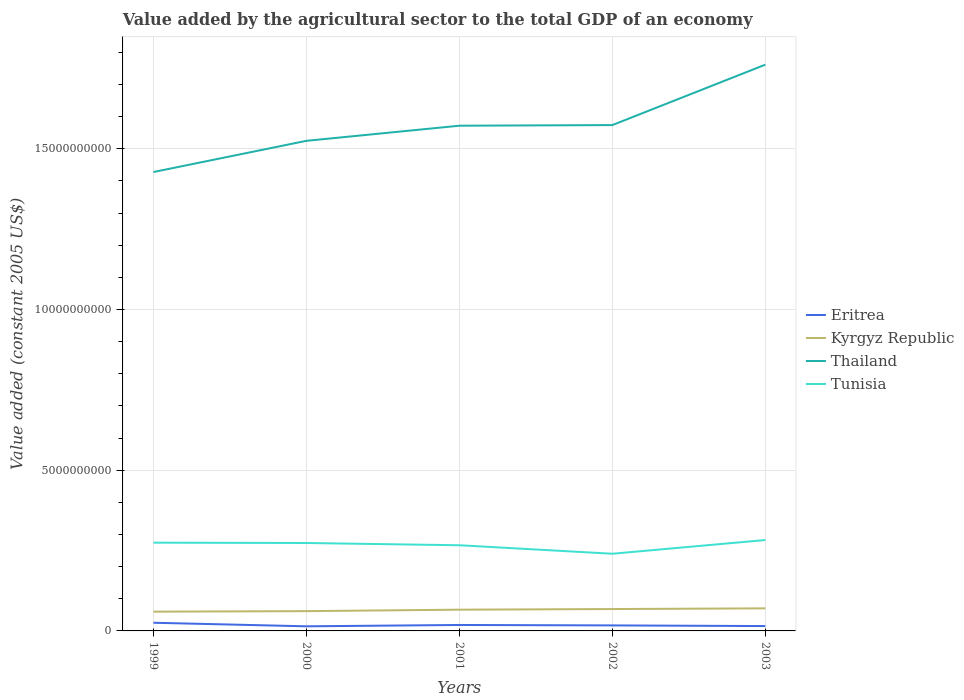Across all years, what is the maximum value added by the agricultural sector in Tunisia?
Ensure brevity in your answer.  2.40e+09. In which year was the value added by the agricultural sector in Kyrgyz Republic maximum?
Offer a terse response. 1999. What is the total value added by the agricultural sector in Eritrea in the graph?
Ensure brevity in your answer.  2.03e+07. What is the difference between the highest and the second highest value added by the agricultural sector in Kyrgyz Republic?
Ensure brevity in your answer.  1.03e+08. How many lines are there?
Your response must be concise. 4. Are the values on the major ticks of Y-axis written in scientific E-notation?
Your response must be concise. No. Does the graph contain any zero values?
Provide a succinct answer. No. What is the title of the graph?
Provide a short and direct response. Value added by the agricultural sector to the total GDP of an economy. What is the label or title of the X-axis?
Offer a terse response. Years. What is the label or title of the Y-axis?
Keep it short and to the point. Value added (constant 2005 US$). What is the Value added (constant 2005 US$) in Eritrea in 1999?
Give a very brief answer. 2.54e+08. What is the Value added (constant 2005 US$) of Kyrgyz Republic in 1999?
Ensure brevity in your answer.  5.99e+08. What is the Value added (constant 2005 US$) in Thailand in 1999?
Keep it short and to the point. 1.43e+1. What is the Value added (constant 2005 US$) of Tunisia in 1999?
Your answer should be very brief. 2.75e+09. What is the Value added (constant 2005 US$) of Eritrea in 2000?
Provide a succinct answer. 1.44e+08. What is the Value added (constant 2005 US$) of Kyrgyz Republic in 2000?
Your answer should be very brief. 6.15e+08. What is the Value added (constant 2005 US$) of Thailand in 2000?
Provide a succinct answer. 1.52e+1. What is the Value added (constant 2005 US$) of Tunisia in 2000?
Your answer should be compact. 2.74e+09. What is the Value added (constant 2005 US$) of Eritrea in 2001?
Your response must be concise. 1.85e+08. What is the Value added (constant 2005 US$) in Kyrgyz Republic in 2001?
Offer a very short reply. 6.61e+08. What is the Value added (constant 2005 US$) of Thailand in 2001?
Ensure brevity in your answer.  1.57e+1. What is the Value added (constant 2005 US$) of Tunisia in 2001?
Provide a short and direct response. 2.67e+09. What is the Value added (constant 2005 US$) in Eritrea in 2002?
Offer a very short reply. 1.71e+08. What is the Value added (constant 2005 US$) in Kyrgyz Republic in 2002?
Your answer should be compact. 6.81e+08. What is the Value added (constant 2005 US$) in Thailand in 2002?
Your answer should be very brief. 1.57e+1. What is the Value added (constant 2005 US$) in Tunisia in 2002?
Offer a very short reply. 2.40e+09. What is the Value added (constant 2005 US$) in Eritrea in 2003?
Keep it short and to the point. 1.51e+08. What is the Value added (constant 2005 US$) of Kyrgyz Republic in 2003?
Your answer should be very brief. 7.02e+08. What is the Value added (constant 2005 US$) in Thailand in 2003?
Keep it short and to the point. 1.76e+1. What is the Value added (constant 2005 US$) of Tunisia in 2003?
Your answer should be compact. 2.83e+09. Across all years, what is the maximum Value added (constant 2005 US$) in Eritrea?
Your response must be concise. 2.54e+08. Across all years, what is the maximum Value added (constant 2005 US$) in Kyrgyz Republic?
Your answer should be compact. 7.02e+08. Across all years, what is the maximum Value added (constant 2005 US$) of Thailand?
Provide a short and direct response. 1.76e+1. Across all years, what is the maximum Value added (constant 2005 US$) of Tunisia?
Provide a succinct answer. 2.83e+09. Across all years, what is the minimum Value added (constant 2005 US$) in Eritrea?
Ensure brevity in your answer.  1.44e+08. Across all years, what is the minimum Value added (constant 2005 US$) in Kyrgyz Republic?
Offer a terse response. 5.99e+08. Across all years, what is the minimum Value added (constant 2005 US$) in Thailand?
Make the answer very short. 1.43e+1. Across all years, what is the minimum Value added (constant 2005 US$) in Tunisia?
Ensure brevity in your answer.  2.40e+09. What is the total Value added (constant 2005 US$) of Eritrea in the graph?
Ensure brevity in your answer.  9.06e+08. What is the total Value added (constant 2005 US$) of Kyrgyz Republic in the graph?
Your response must be concise. 3.26e+09. What is the total Value added (constant 2005 US$) of Thailand in the graph?
Your answer should be compact. 7.86e+1. What is the total Value added (constant 2005 US$) in Tunisia in the graph?
Your answer should be compact. 1.34e+1. What is the difference between the Value added (constant 2005 US$) of Eritrea in 1999 and that in 2000?
Your answer should be very brief. 1.11e+08. What is the difference between the Value added (constant 2005 US$) in Kyrgyz Republic in 1999 and that in 2000?
Your answer should be compact. -1.61e+07. What is the difference between the Value added (constant 2005 US$) of Thailand in 1999 and that in 2000?
Give a very brief answer. -9.71e+08. What is the difference between the Value added (constant 2005 US$) of Tunisia in 1999 and that in 2000?
Your response must be concise. 1.05e+07. What is the difference between the Value added (constant 2005 US$) of Eritrea in 1999 and that in 2001?
Provide a short and direct response. 6.87e+07. What is the difference between the Value added (constant 2005 US$) in Kyrgyz Republic in 1999 and that in 2001?
Give a very brief answer. -6.16e+07. What is the difference between the Value added (constant 2005 US$) of Thailand in 1999 and that in 2001?
Offer a terse response. -1.44e+09. What is the difference between the Value added (constant 2005 US$) in Tunisia in 1999 and that in 2001?
Give a very brief answer. 8.04e+07. What is the difference between the Value added (constant 2005 US$) of Eritrea in 1999 and that in 2002?
Your response must be concise. 8.26e+07. What is the difference between the Value added (constant 2005 US$) in Kyrgyz Republic in 1999 and that in 2002?
Offer a terse response. -8.12e+07. What is the difference between the Value added (constant 2005 US$) in Thailand in 1999 and that in 2002?
Ensure brevity in your answer.  -1.46e+09. What is the difference between the Value added (constant 2005 US$) of Tunisia in 1999 and that in 2002?
Keep it short and to the point. 3.45e+08. What is the difference between the Value added (constant 2005 US$) in Eritrea in 1999 and that in 2003?
Offer a very short reply. 1.03e+08. What is the difference between the Value added (constant 2005 US$) in Kyrgyz Republic in 1999 and that in 2003?
Your response must be concise. -1.03e+08. What is the difference between the Value added (constant 2005 US$) in Thailand in 1999 and that in 2003?
Offer a terse response. -3.34e+09. What is the difference between the Value added (constant 2005 US$) in Tunisia in 1999 and that in 2003?
Offer a very short reply. -8.19e+07. What is the difference between the Value added (constant 2005 US$) of Eritrea in 2000 and that in 2001?
Your response must be concise. -4.18e+07. What is the difference between the Value added (constant 2005 US$) of Kyrgyz Republic in 2000 and that in 2001?
Ensure brevity in your answer.  -4.55e+07. What is the difference between the Value added (constant 2005 US$) in Thailand in 2000 and that in 2001?
Make the answer very short. -4.70e+08. What is the difference between the Value added (constant 2005 US$) of Tunisia in 2000 and that in 2001?
Offer a terse response. 7.00e+07. What is the difference between the Value added (constant 2005 US$) of Eritrea in 2000 and that in 2002?
Make the answer very short. -2.79e+07. What is the difference between the Value added (constant 2005 US$) in Kyrgyz Republic in 2000 and that in 2002?
Your answer should be very brief. -6.51e+07. What is the difference between the Value added (constant 2005 US$) in Thailand in 2000 and that in 2002?
Your response must be concise. -4.90e+08. What is the difference between the Value added (constant 2005 US$) of Tunisia in 2000 and that in 2002?
Keep it short and to the point. 3.34e+08. What is the difference between the Value added (constant 2005 US$) in Eritrea in 2000 and that in 2003?
Ensure brevity in your answer.  -7.56e+06. What is the difference between the Value added (constant 2005 US$) in Kyrgyz Republic in 2000 and that in 2003?
Your response must be concise. -8.69e+07. What is the difference between the Value added (constant 2005 US$) in Thailand in 2000 and that in 2003?
Your answer should be compact. -2.37e+09. What is the difference between the Value added (constant 2005 US$) in Tunisia in 2000 and that in 2003?
Provide a short and direct response. -9.24e+07. What is the difference between the Value added (constant 2005 US$) of Eritrea in 2001 and that in 2002?
Your response must be concise. 1.40e+07. What is the difference between the Value added (constant 2005 US$) in Kyrgyz Republic in 2001 and that in 2002?
Your answer should be very brief. -1.96e+07. What is the difference between the Value added (constant 2005 US$) in Thailand in 2001 and that in 2002?
Your answer should be compact. -1.94e+07. What is the difference between the Value added (constant 2005 US$) in Tunisia in 2001 and that in 2002?
Make the answer very short. 2.64e+08. What is the difference between the Value added (constant 2005 US$) in Eritrea in 2001 and that in 2003?
Ensure brevity in your answer.  3.43e+07. What is the difference between the Value added (constant 2005 US$) in Kyrgyz Republic in 2001 and that in 2003?
Offer a very short reply. -4.14e+07. What is the difference between the Value added (constant 2005 US$) in Thailand in 2001 and that in 2003?
Ensure brevity in your answer.  -1.90e+09. What is the difference between the Value added (constant 2005 US$) of Tunisia in 2001 and that in 2003?
Provide a succinct answer. -1.62e+08. What is the difference between the Value added (constant 2005 US$) in Eritrea in 2002 and that in 2003?
Your answer should be compact. 2.03e+07. What is the difference between the Value added (constant 2005 US$) of Kyrgyz Republic in 2002 and that in 2003?
Make the answer very short. -2.17e+07. What is the difference between the Value added (constant 2005 US$) of Thailand in 2002 and that in 2003?
Give a very brief answer. -1.88e+09. What is the difference between the Value added (constant 2005 US$) in Tunisia in 2002 and that in 2003?
Give a very brief answer. -4.27e+08. What is the difference between the Value added (constant 2005 US$) of Eritrea in 1999 and the Value added (constant 2005 US$) of Kyrgyz Republic in 2000?
Your answer should be compact. -3.61e+08. What is the difference between the Value added (constant 2005 US$) in Eritrea in 1999 and the Value added (constant 2005 US$) in Thailand in 2000?
Your answer should be very brief. -1.50e+1. What is the difference between the Value added (constant 2005 US$) in Eritrea in 1999 and the Value added (constant 2005 US$) in Tunisia in 2000?
Offer a very short reply. -2.48e+09. What is the difference between the Value added (constant 2005 US$) in Kyrgyz Republic in 1999 and the Value added (constant 2005 US$) in Thailand in 2000?
Your answer should be very brief. -1.46e+1. What is the difference between the Value added (constant 2005 US$) in Kyrgyz Republic in 1999 and the Value added (constant 2005 US$) in Tunisia in 2000?
Ensure brevity in your answer.  -2.14e+09. What is the difference between the Value added (constant 2005 US$) in Thailand in 1999 and the Value added (constant 2005 US$) in Tunisia in 2000?
Offer a terse response. 1.15e+1. What is the difference between the Value added (constant 2005 US$) in Eritrea in 1999 and the Value added (constant 2005 US$) in Kyrgyz Republic in 2001?
Your answer should be very brief. -4.07e+08. What is the difference between the Value added (constant 2005 US$) in Eritrea in 1999 and the Value added (constant 2005 US$) in Thailand in 2001?
Your answer should be very brief. -1.55e+1. What is the difference between the Value added (constant 2005 US$) of Eritrea in 1999 and the Value added (constant 2005 US$) of Tunisia in 2001?
Ensure brevity in your answer.  -2.41e+09. What is the difference between the Value added (constant 2005 US$) in Kyrgyz Republic in 1999 and the Value added (constant 2005 US$) in Thailand in 2001?
Offer a very short reply. -1.51e+1. What is the difference between the Value added (constant 2005 US$) of Kyrgyz Republic in 1999 and the Value added (constant 2005 US$) of Tunisia in 2001?
Your answer should be compact. -2.07e+09. What is the difference between the Value added (constant 2005 US$) in Thailand in 1999 and the Value added (constant 2005 US$) in Tunisia in 2001?
Offer a terse response. 1.16e+1. What is the difference between the Value added (constant 2005 US$) of Eritrea in 1999 and the Value added (constant 2005 US$) of Kyrgyz Republic in 2002?
Your answer should be compact. -4.27e+08. What is the difference between the Value added (constant 2005 US$) in Eritrea in 1999 and the Value added (constant 2005 US$) in Thailand in 2002?
Provide a short and direct response. -1.55e+1. What is the difference between the Value added (constant 2005 US$) in Eritrea in 1999 and the Value added (constant 2005 US$) in Tunisia in 2002?
Your response must be concise. -2.15e+09. What is the difference between the Value added (constant 2005 US$) in Kyrgyz Republic in 1999 and the Value added (constant 2005 US$) in Thailand in 2002?
Your response must be concise. -1.51e+1. What is the difference between the Value added (constant 2005 US$) of Kyrgyz Republic in 1999 and the Value added (constant 2005 US$) of Tunisia in 2002?
Give a very brief answer. -1.80e+09. What is the difference between the Value added (constant 2005 US$) in Thailand in 1999 and the Value added (constant 2005 US$) in Tunisia in 2002?
Keep it short and to the point. 1.19e+1. What is the difference between the Value added (constant 2005 US$) in Eritrea in 1999 and the Value added (constant 2005 US$) in Kyrgyz Republic in 2003?
Provide a succinct answer. -4.48e+08. What is the difference between the Value added (constant 2005 US$) in Eritrea in 1999 and the Value added (constant 2005 US$) in Thailand in 2003?
Make the answer very short. -1.74e+1. What is the difference between the Value added (constant 2005 US$) in Eritrea in 1999 and the Value added (constant 2005 US$) in Tunisia in 2003?
Provide a short and direct response. -2.57e+09. What is the difference between the Value added (constant 2005 US$) in Kyrgyz Republic in 1999 and the Value added (constant 2005 US$) in Thailand in 2003?
Provide a succinct answer. -1.70e+1. What is the difference between the Value added (constant 2005 US$) in Kyrgyz Republic in 1999 and the Value added (constant 2005 US$) in Tunisia in 2003?
Keep it short and to the point. -2.23e+09. What is the difference between the Value added (constant 2005 US$) of Thailand in 1999 and the Value added (constant 2005 US$) of Tunisia in 2003?
Your response must be concise. 1.14e+1. What is the difference between the Value added (constant 2005 US$) in Eritrea in 2000 and the Value added (constant 2005 US$) in Kyrgyz Republic in 2001?
Keep it short and to the point. -5.17e+08. What is the difference between the Value added (constant 2005 US$) in Eritrea in 2000 and the Value added (constant 2005 US$) in Thailand in 2001?
Make the answer very short. -1.56e+1. What is the difference between the Value added (constant 2005 US$) in Eritrea in 2000 and the Value added (constant 2005 US$) in Tunisia in 2001?
Offer a terse response. -2.52e+09. What is the difference between the Value added (constant 2005 US$) of Kyrgyz Republic in 2000 and the Value added (constant 2005 US$) of Thailand in 2001?
Provide a short and direct response. -1.51e+1. What is the difference between the Value added (constant 2005 US$) in Kyrgyz Republic in 2000 and the Value added (constant 2005 US$) in Tunisia in 2001?
Your response must be concise. -2.05e+09. What is the difference between the Value added (constant 2005 US$) of Thailand in 2000 and the Value added (constant 2005 US$) of Tunisia in 2001?
Make the answer very short. 1.26e+1. What is the difference between the Value added (constant 2005 US$) in Eritrea in 2000 and the Value added (constant 2005 US$) in Kyrgyz Republic in 2002?
Ensure brevity in your answer.  -5.37e+08. What is the difference between the Value added (constant 2005 US$) in Eritrea in 2000 and the Value added (constant 2005 US$) in Thailand in 2002?
Keep it short and to the point. -1.56e+1. What is the difference between the Value added (constant 2005 US$) of Eritrea in 2000 and the Value added (constant 2005 US$) of Tunisia in 2002?
Make the answer very short. -2.26e+09. What is the difference between the Value added (constant 2005 US$) of Kyrgyz Republic in 2000 and the Value added (constant 2005 US$) of Thailand in 2002?
Give a very brief answer. -1.51e+1. What is the difference between the Value added (constant 2005 US$) in Kyrgyz Republic in 2000 and the Value added (constant 2005 US$) in Tunisia in 2002?
Offer a very short reply. -1.79e+09. What is the difference between the Value added (constant 2005 US$) of Thailand in 2000 and the Value added (constant 2005 US$) of Tunisia in 2002?
Your response must be concise. 1.28e+1. What is the difference between the Value added (constant 2005 US$) in Eritrea in 2000 and the Value added (constant 2005 US$) in Kyrgyz Republic in 2003?
Your answer should be compact. -5.59e+08. What is the difference between the Value added (constant 2005 US$) in Eritrea in 2000 and the Value added (constant 2005 US$) in Thailand in 2003?
Your response must be concise. -1.75e+1. What is the difference between the Value added (constant 2005 US$) of Eritrea in 2000 and the Value added (constant 2005 US$) of Tunisia in 2003?
Your response must be concise. -2.68e+09. What is the difference between the Value added (constant 2005 US$) of Kyrgyz Republic in 2000 and the Value added (constant 2005 US$) of Thailand in 2003?
Provide a succinct answer. -1.70e+1. What is the difference between the Value added (constant 2005 US$) of Kyrgyz Republic in 2000 and the Value added (constant 2005 US$) of Tunisia in 2003?
Your response must be concise. -2.21e+09. What is the difference between the Value added (constant 2005 US$) in Thailand in 2000 and the Value added (constant 2005 US$) in Tunisia in 2003?
Offer a very short reply. 1.24e+1. What is the difference between the Value added (constant 2005 US$) of Eritrea in 2001 and the Value added (constant 2005 US$) of Kyrgyz Republic in 2002?
Offer a terse response. -4.95e+08. What is the difference between the Value added (constant 2005 US$) of Eritrea in 2001 and the Value added (constant 2005 US$) of Thailand in 2002?
Make the answer very short. -1.56e+1. What is the difference between the Value added (constant 2005 US$) in Eritrea in 2001 and the Value added (constant 2005 US$) in Tunisia in 2002?
Your answer should be compact. -2.22e+09. What is the difference between the Value added (constant 2005 US$) of Kyrgyz Republic in 2001 and the Value added (constant 2005 US$) of Thailand in 2002?
Offer a terse response. -1.51e+1. What is the difference between the Value added (constant 2005 US$) in Kyrgyz Republic in 2001 and the Value added (constant 2005 US$) in Tunisia in 2002?
Your answer should be very brief. -1.74e+09. What is the difference between the Value added (constant 2005 US$) of Thailand in 2001 and the Value added (constant 2005 US$) of Tunisia in 2002?
Keep it short and to the point. 1.33e+1. What is the difference between the Value added (constant 2005 US$) in Eritrea in 2001 and the Value added (constant 2005 US$) in Kyrgyz Republic in 2003?
Give a very brief answer. -5.17e+08. What is the difference between the Value added (constant 2005 US$) of Eritrea in 2001 and the Value added (constant 2005 US$) of Thailand in 2003?
Make the answer very short. -1.74e+1. What is the difference between the Value added (constant 2005 US$) in Eritrea in 2001 and the Value added (constant 2005 US$) in Tunisia in 2003?
Ensure brevity in your answer.  -2.64e+09. What is the difference between the Value added (constant 2005 US$) in Kyrgyz Republic in 2001 and the Value added (constant 2005 US$) in Thailand in 2003?
Your answer should be compact. -1.70e+1. What is the difference between the Value added (constant 2005 US$) in Kyrgyz Republic in 2001 and the Value added (constant 2005 US$) in Tunisia in 2003?
Offer a very short reply. -2.17e+09. What is the difference between the Value added (constant 2005 US$) in Thailand in 2001 and the Value added (constant 2005 US$) in Tunisia in 2003?
Provide a succinct answer. 1.29e+1. What is the difference between the Value added (constant 2005 US$) of Eritrea in 2002 and the Value added (constant 2005 US$) of Kyrgyz Republic in 2003?
Offer a terse response. -5.31e+08. What is the difference between the Value added (constant 2005 US$) of Eritrea in 2002 and the Value added (constant 2005 US$) of Thailand in 2003?
Your answer should be compact. -1.74e+1. What is the difference between the Value added (constant 2005 US$) of Eritrea in 2002 and the Value added (constant 2005 US$) of Tunisia in 2003?
Provide a succinct answer. -2.66e+09. What is the difference between the Value added (constant 2005 US$) of Kyrgyz Republic in 2002 and the Value added (constant 2005 US$) of Thailand in 2003?
Offer a very short reply. -1.69e+1. What is the difference between the Value added (constant 2005 US$) of Kyrgyz Republic in 2002 and the Value added (constant 2005 US$) of Tunisia in 2003?
Your response must be concise. -2.15e+09. What is the difference between the Value added (constant 2005 US$) in Thailand in 2002 and the Value added (constant 2005 US$) in Tunisia in 2003?
Make the answer very short. 1.29e+1. What is the average Value added (constant 2005 US$) of Eritrea per year?
Your answer should be very brief. 1.81e+08. What is the average Value added (constant 2005 US$) of Kyrgyz Republic per year?
Give a very brief answer. 6.52e+08. What is the average Value added (constant 2005 US$) of Thailand per year?
Make the answer very short. 1.57e+1. What is the average Value added (constant 2005 US$) in Tunisia per year?
Give a very brief answer. 2.68e+09. In the year 1999, what is the difference between the Value added (constant 2005 US$) of Eritrea and Value added (constant 2005 US$) of Kyrgyz Republic?
Your response must be concise. -3.45e+08. In the year 1999, what is the difference between the Value added (constant 2005 US$) of Eritrea and Value added (constant 2005 US$) of Thailand?
Ensure brevity in your answer.  -1.40e+1. In the year 1999, what is the difference between the Value added (constant 2005 US$) in Eritrea and Value added (constant 2005 US$) in Tunisia?
Keep it short and to the point. -2.49e+09. In the year 1999, what is the difference between the Value added (constant 2005 US$) in Kyrgyz Republic and Value added (constant 2005 US$) in Thailand?
Your answer should be very brief. -1.37e+1. In the year 1999, what is the difference between the Value added (constant 2005 US$) of Kyrgyz Republic and Value added (constant 2005 US$) of Tunisia?
Keep it short and to the point. -2.15e+09. In the year 1999, what is the difference between the Value added (constant 2005 US$) of Thailand and Value added (constant 2005 US$) of Tunisia?
Your answer should be compact. 1.15e+1. In the year 2000, what is the difference between the Value added (constant 2005 US$) of Eritrea and Value added (constant 2005 US$) of Kyrgyz Republic?
Provide a succinct answer. -4.72e+08. In the year 2000, what is the difference between the Value added (constant 2005 US$) of Eritrea and Value added (constant 2005 US$) of Thailand?
Your answer should be compact. -1.51e+1. In the year 2000, what is the difference between the Value added (constant 2005 US$) of Eritrea and Value added (constant 2005 US$) of Tunisia?
Offer a terse response. -2.59e+09. In the year 2000, what is the difference between the Value added (constant 2005 US$) of Kyrgyz Republic and Value added (constant 2005 US$) of Thailand?
Offer a terse response. -1.46e+1. In the year 2000, what is the difference between the Value added (constant 2005 US$) of Kyrgyz Republic and Value added (constant 2005 US$) of Tunisia?
Make the answer very short. -2.12e+09. In the year 2000, what is the difference between the Value added (constant 2005 US$) of Thailand and Value added (constant 2005 US$) of Tunisia?
Ensure brevity in your answer.  1.25e+1. In the year 2001, what is the difference between the Value added (constant 2005 US$) of Eritrea and Value added (constant 2005 US$) of Kyrgyz Republic?
Provide a succinct answer. -4.76e+08. In the year 2001, what is the difference between the Value added (constant 2005 US$) in Eritrea and Value added (constant 2005 US$) in Thailand?
Keep it short and to the point. -1.55e+1. In the year 2001, what is the difference between the Value added (constant 2005 US$) in Eritrea and Value added (constant 2005 US$) in Tunisia?
Provide a short and direct response. -2.48e+09. In the year 2001, what is the difference between the Value added (constant 2005 US$) in Kyrgyz Republic and Value added (constant 2005 US$) in Thailand?
Give a very brief answer. -1.51e+1. In the year 2001, what is the difference between the Value added (constant 2005 US$) in Kyrgyz Republic and Value added (constant 2005 US$) in Tunisia?
Make the answer very short. -2.00e+09. In the year 2001, what is the difference between the Value added (constant 2005 US$) in Thailand and Value added (constant 2005 US$) in Tunisia?
Your answer should be compact. 1.31e+1. In the year 2002, what is the difference between the Value added (constant 2005 US$) in Eritrea and Value added (constant 2005 US$) in Kyrgyz Republic?
Your answer should be very brief. -5.09e+08. In the year 2002, what is the difference between the Value added (constant 2005 US$) in Eritrea and Value added (constant 2005 US$) in Thailand?
Offer a terse response. -1.56e+1. In the year 2002, what is the difference between the Value added (constant 2005 US$) in Eritrea and Value added (constant 2005 US$) in Tunisia?
Keep it short and to the point. -2.23e+09. In the year 2002, what is the difference between the Value added (constant 2005 US$) of Kyrgyz Republic and Value added (constant 2005 US$) of Thailand?
Provide a short and direct response. -1.51e+1. In the year 2002, what is the difference between the Value added (constant 2005 US$) of Kyrgyz Republic and Value added (constant 2005 US$) of Tunisia?
Keep it short and to the point. -1.72e+09. In the year 2002, what is the difference between the Value added (constant 2005 US$) in Thailand and Value added (constant 2005 US$) in Tunisia?
Offer a terse response. 1.33e+1. In the year 2003, what is the difference between the Value added (constant 2005 US$) in Eritrea and Value added (constant 2005 US$) in Kyrgyz Republic?
Give a very brief answer. -5.51e+08. In the year 2003, what is the difference between the Value added (constant 2005 US$) of Eritrea and Value added (constant 2005 US$) of Thailand?
Offer a very short reply. -1.75e+1. In the year 2003, what is the difference between the Value added (constant 2005 US$) in Eritrea and Value added (constant 2005 US$) in Tunisia?
Offer a terse response. -2.68e+09. In the year 2003, what is the difference between the Value added (constant 2005 US$) of Kyrgyz Republic and Value added (constant 2005 US$) of Thailand?
Your answer should be compact. -1.69e+1. In the year 2003, what is the difference between the Value added (constant 2005 US$) of Kyrgyz Republic and Value added (constant 2005 US$) of Tunisia?
Your answer should be very brief. -2.13e+09. In the year 2003, what is the difference between the Value added (constant 2005 US$) in Thailand and Value added (constant 2005 US$) in Tunisia?
Keep it short and to the point. 1.48e+1. What is the ratio of the Value added (constant 2005 US$) of Eritrea in 1999 to that in 2000?
Your response must be concise. 1.77. What is the ratio of the Value added (constant 2005 US$) in Kyrgyz Republic in 1999 to that in 2000?
Your answer should be very brief. 0.97. What is the ratio of the Value added (constant 2005 US$) of Thailand in 1999 to that in 2000?
Your answer should be compact. 0.94. What is the ratio of the Value added (constant 2005 US$) of Tunisia in 1999 to that in 2000?
Your answer should be compact. 1. What is the ratio of the Value added (constant 2005 US$) in Eritrea in 1999 to that in 2001?
Your answer should be very brief. 1.37. What is the ratio of the Value added (constant 2005 US$) in Kyrgyz Republic in 1999 to that in 2001?
Offer a very short reply. 0.91. What is the ratio of the Value added (constant 2005 US$) of Thailand in 1999 to that in 2001?
Your response must be concise. 0.91. What is the ratio of the Value added (constant 2005 US$) in Tunisia in 1999 to that in 2001?
Your answer should be very brief. 1.03. What is the ratio of the Value added (constant 2005 US$) of Eritrea in 1999 to that in 2002?
Ensure brevity in your answer.  1.48. What is the ratio of the Value added (constant 2005 US$) in Kyrgyz Republic in 1999 to that in 2002?
Provide a short and direct response. 0.88. What is the ratio of the Value added (constant 2005 US$) of Thailand in 1999 to that in 2002?
Your answer should be compact. 0.91. What is the ratio of the Value added (constant 2005 US$) of Tunisia in 1999 to that in 2002?
Your response must be concise. 1.14. What is the ratio of the Value added (constant 2005 US$) in Eritrea in 1999 to that in 2003?
Provide a succinct answer. 1.68. What is the ratio of the Value added (constant 2005 US$) in Kyrgyz Republic in 1999 to that in 2003?
Provide a succinct answer. 0.85. What is the ratio of the Value added (constant 2005 US$) in Thailand in 1999 to that in 2003?
Your response must be concise. 0.81. What is the ratio of the Value added (constant 2005 US$) of Tunisia in 1999 to that in 2003?
Keep it short and to the point. 0.97. What is the ratio of the Value added (constant 2005 US$) of Eritrea in 2000 to that in 2001?
Make the answer very short. 0.77. What is the ratio of the Value added (constant 2005 US$) in Kyrgyz Republic in 2000 to that in 2001?
Offer a very short reply. 0.93. What is the ratio of the Value added (constant 2005 US$) of Thailand in 2000 to that in 2001?
Offer a very short reply. 0.97. What is the ratio of the Value added (constant 2005 US$) in Tunisia in 2000 to that in 2001?
Provide a succinct answer. 1.03. What is the ratio of the Value added (constant 2005 US$) in Eritrea in 2000 to that in 2002?
Keep it short and to the point. 0.84. What is the ratio of the Value added (constant 2005 US$) in Kyrgyz Republic in 2000 to that in 2002?
Provide a succinct answer. 0.9. What is the ratio of the Value added (constant 2005 US$) in Thailand in 2000 to that in 2002?
Keep it short and to the point. 0.97. What is the ratio of the Value added (constant 2005 US$) of Tunisia in 2000 to that in 2002?
Make the answer very short. 1.14. What is the ratio of the Value added (constant 2005 US$) of Kyrgyz Republic in 2000 to that in 2003?
Your answer should be very brief. 0.88. What is the ratio of the Value added (constant 2005 US$) in Thailand in 2000 to that in 2003?
Your response must be concise. 0.87. What is the ratio of the Value added (constant 2005 US$) in Tunisia in 2000 to that in 2003?
Ensure brevity in your answer.  0.97. What is the ratio of the Value added (constant 2005 US$) in Eritrea in 2001 to that in 2002?
Your response must be concise. 1.08. What is the ratio of the Value added (constant 2005 US$) in Kyrgyz Republic in 2001 to that in 2002?
Your answer should be compact. 0.97. What is the ratio of the Value added (constant 2005 US$) in Tunisia in 2001 to that in 2002?
Offer a very short reply. 1.11. What is the ratio of the Value added (constant 2005 US$) of Eritrea in 2001 to that in 2003?
Keep it short and to the point. 1.23. What is the ratio of the Value added (constant 2005 US$) in Kyrgyz Republic in 2001 to that in 2003?
Your response must be concise. 0.94. What is the ratio of the Value added (constant 2005 US$) in Thailand in 2001 to that in 2003?
Give a very brief answer. 0.89. What is the ratio of the Value added (constant 2005 US$) in Tunisia in 2001 to that in 2003?
Give a very brief answer. 0.94. What is the ratio of the Value added (constant 2005 US$) in Eritrea in 2002 to that in 2003?
Offer a very short reply. 1.13. What is the ratio of the Value added (constant 2005 US$) in Kyrgyz Republic in 2002 to that in 2003?
Your answer should be very brief. 0.97. What is the ratio of the Value added (constant 2005 US$) in Thailand in 2002 to that in 2003?
Your answer should be very brief. 0.89. What is the ratio of the Value added (constant 2005 US$) in Tunisia in 2002 to that in 2003?
Your answer should be compact. 0.85. What is the difference between the highest and the second highest Value added (constant 2005 US$) of Eritrea?
Provide a short and direct response. 6.87e+07. What is the difference between the highest and the second highest Value added (constant 2005 US$) in Kyrgyz Republic?
Make the answer very short. 2.17e+07. What is the difference between the highest and the second highest Value added (constant 2005 US$) of Thailand?
Your answer should be very brief. 1.88e+09. What is the difference between the highest and the second highest Value added (constant 2005 US$) of Tunisia?
Offer a terse response. 8.19e+07. What is the difference between the highest and the lowest Value added (constant 2005 US$) of Eritrea?
Ensure brevity in your answer.  1.11e+08. What is the difference between the highest and the lowest Value added (constant 2005 US$) in Kyrgyz Republic?
Provide a succinct answer. 1.03e+08. What is the difference between the highest and the lowest Value added (constant 2005 US$) of Thailand?
Your response must be concise. 3.34e+09. What is the difference between the highest and the lowest Value added (constant 2005 US$) of Tunisia?
Your answer should be very brief. 4.27e+08. 